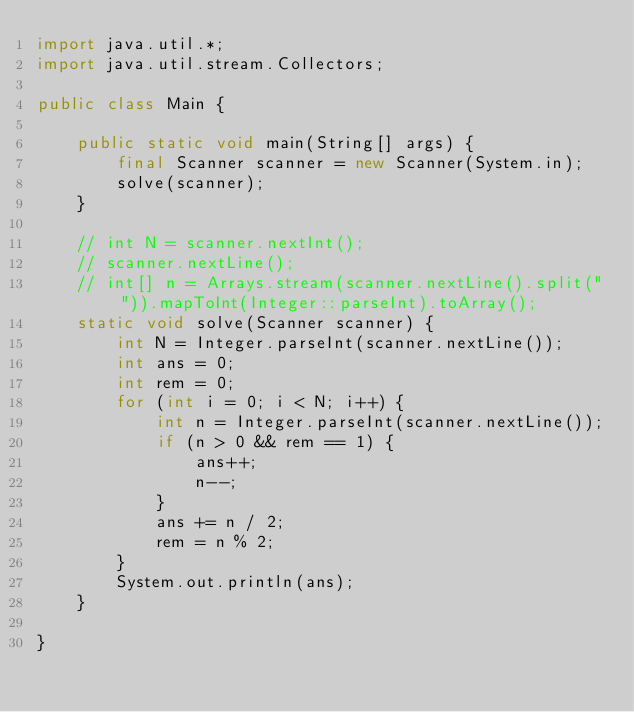Convert code to text. <code><loc_0><loc_0><loc_500><loc_500><_Java_>import java.util.*;
import java.util.stream.Collectors;

public class Main {

    public static void main(String[] args) {
        final Scanner scanner = new Scanner(System.in);
        solve(scanner);
    }

    // int N = scanner.nextInt();
    // scanner.nextLine();
    // int[] n = Arrays.stream(scanner.nextLine().split(" ")).mapToInt(Integer::parseInt).toArray();
    static void solve(Scanner scanner) {
        int N = Integer.parseInt(scanner.nextLine());
        int ans = 0;
        int rem = 0;
        for (int i = 0; i < N; i++) {
            int n = Integer.parseInt(scanner.nextLine());
            if (n > 0 && rem == 1) {
                ans++;
                n--;
            }
            ans += n / 2;
            rem = n % 2;
        }
        System.out.println(ans);
    }

}</code> 